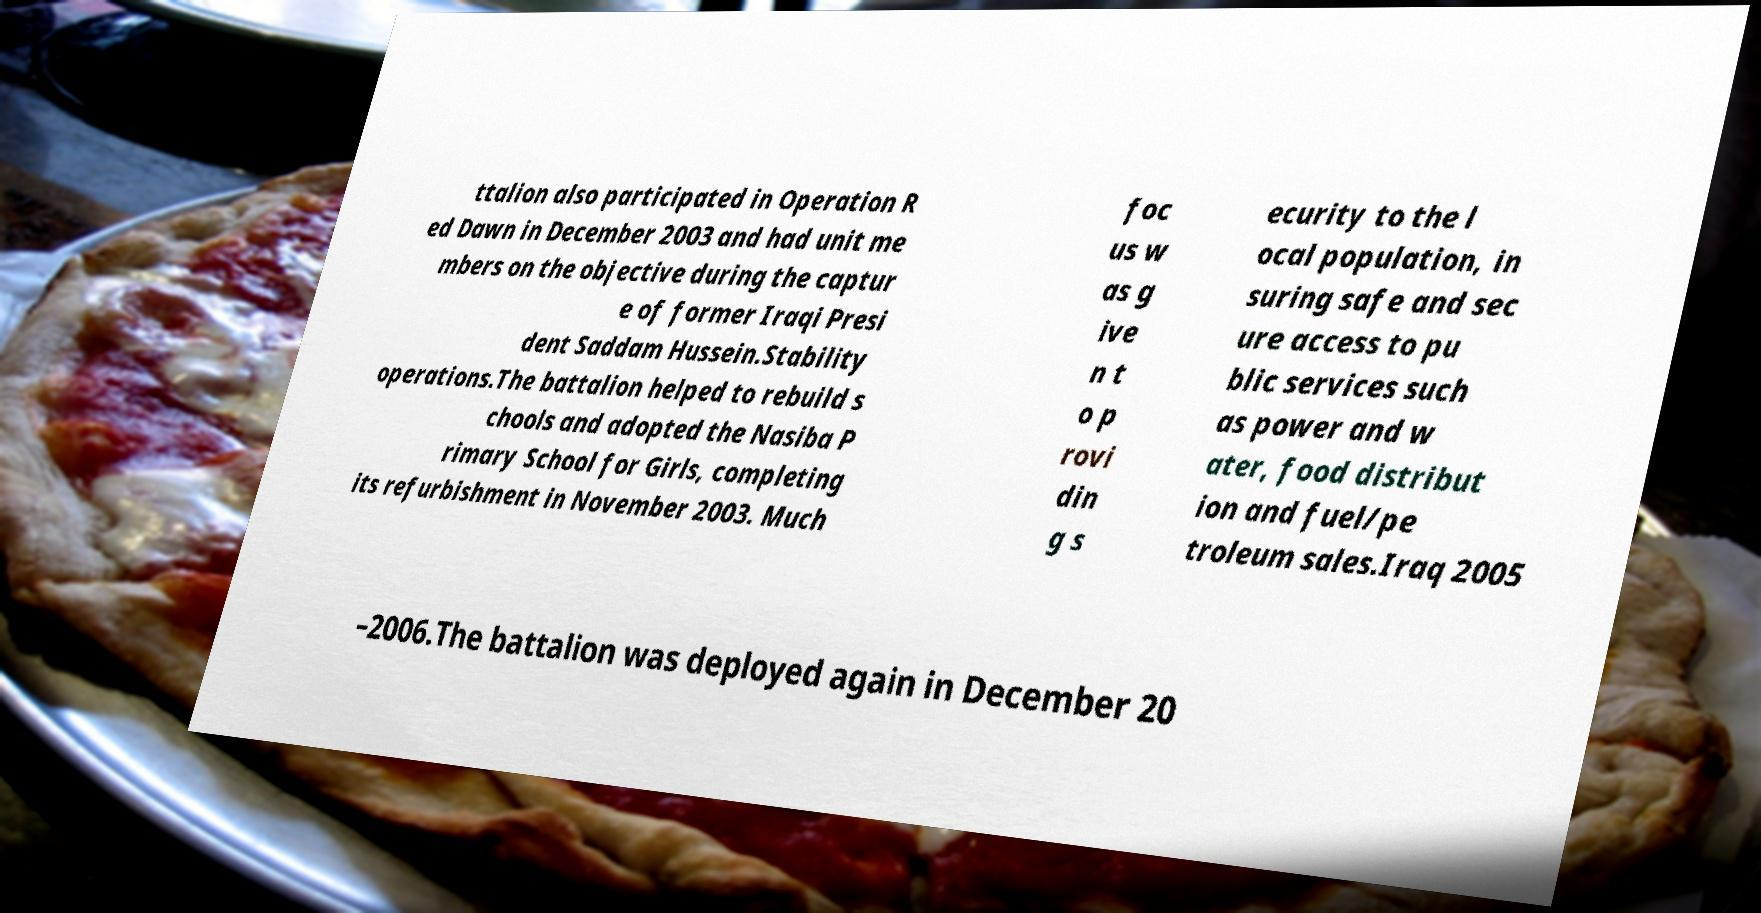Can you accurately transcribe the text from the provided image for me? ttalion also participated in Operation R ed Dawn in December 2003 and had unit me mbers on the objective during the captur e of former Iraqi Presi dent Saddam Hussein.Stability operations.The battalion helped to rebuild s chools and adopted the Nasiba P rimary School for Girls, completing its refurbishment in November 2003. Much foc us w as g ive n t o p rovi din g s ecurity to the l ocal population, in suring safe and sec ure access to pu blic services such as power and w ater, food distribut ion and fuel/pe troleum sales.Iraq 2005 –2006.The battalion was deployed again in December 20 